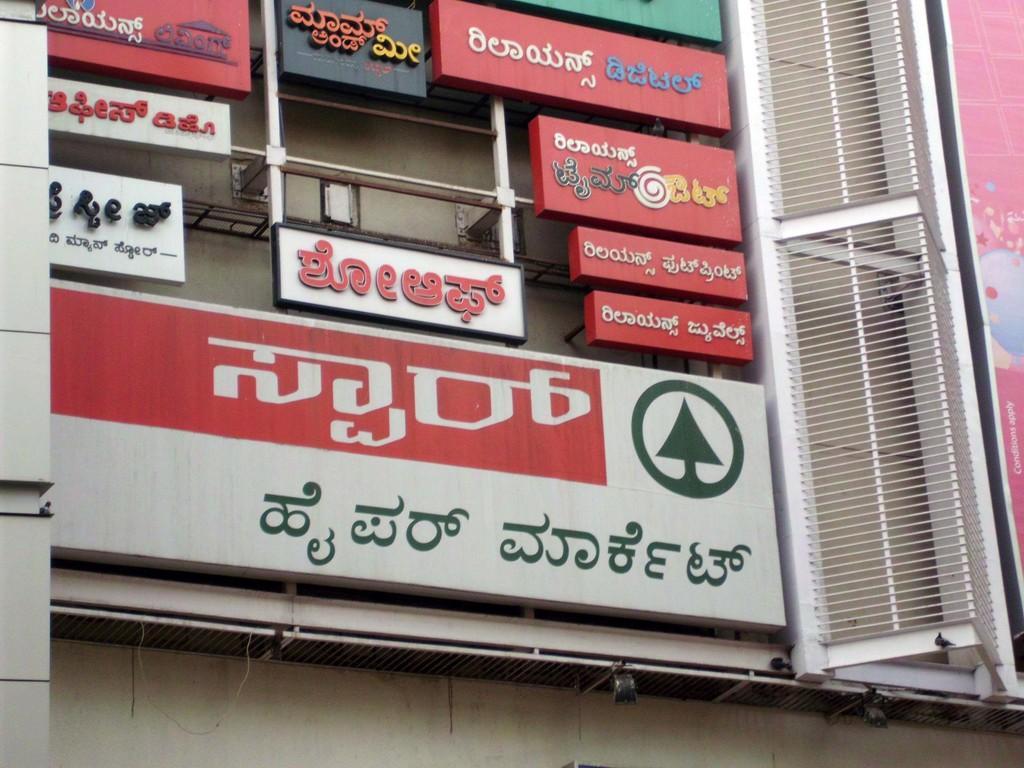Could you give a brief overview of what you see in this image? In the center of the image there is building and there are advertisement boards on the building. 